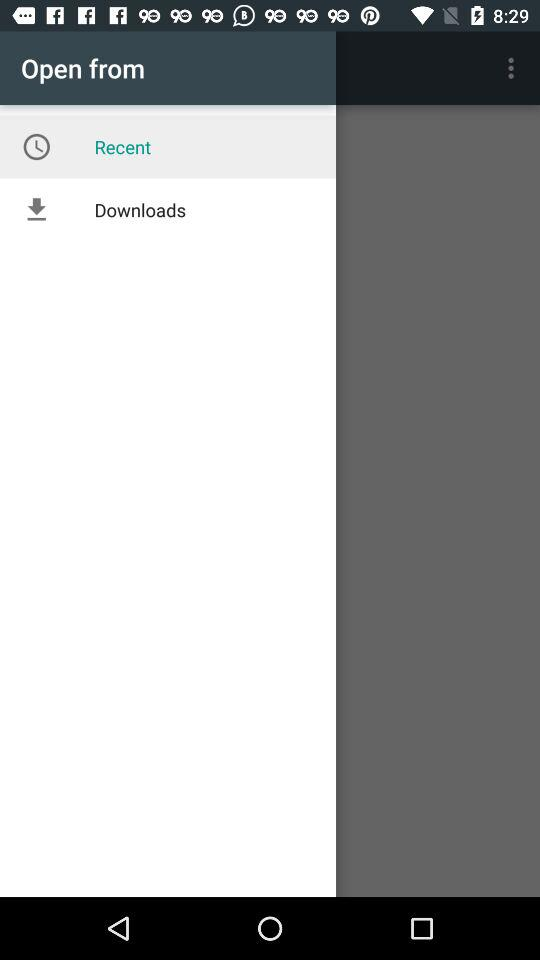What is the selected item in "Open from"? The selected item in "Open from" is "Recent". 